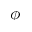Convert formula to latex. <formula><loc_0><loc_0><loc_500><loc_500>\phi</formula> 